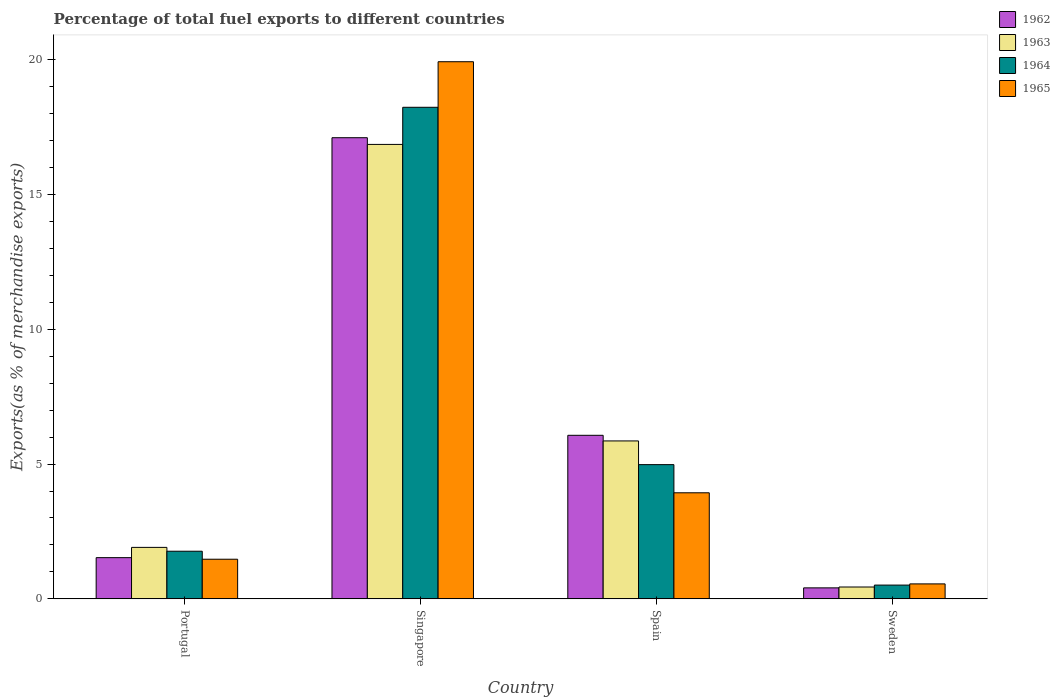How many different coloured bars are there?
Ensure brevity in your answer.  4. Are the number of bars on each tick of the X-axis equal?
Your response must be concise. Yes. How many bars are there on the 4th tick from the left?
Offer a terse response. 4. What is the label of the 3rd group of bars from the left?
Offer a terse response. Spain. What is the percentage of exports to different countries in 1965 in Spain?
Your answer should be very brief. 3.93. Across all countries, what is the maximum percentage of exports to different countries in 1964?
Your answer should be very brief. 18.23. Across all countries, what is the minimum percentage of exports to different countries in 1964?
Make the answer very short. 0.51. In which country was the percentage of exports to different countries in 1965 maximum?
Offer a very short reply. Singapore. What is the total percentage of exports to different countries in 1962 in the graph?
Offer a very short reply. 25.1. What is the difference between the percentage of exports to different countries in 1964 in Portugal and that in Spain?
Offer a very short reply. -3.21. What is the difference between the percentage of exports to different countries in 1963 in Singapore and the percentage of exports to different countries in 1965 in Sweden?
Offer a very short reply. 16.3. What is the average percentage of exports to different countries in 1965 per country?
Make the answer very short. 6.47. What is the difference between the percentage of exports to different countries of/in 1963 and percentage of exports to different countries of/in 1965 in Portugal?
Offer a very short reply. 0.44. In how many countries, is the percentage of exports to different countries in 1962 greater than 3 %?
Give a very brief answer. 2. What is the ratio of the percentage of exports to different countries in 1962 in Singapore to that in Sweden?
Provide a succinct answer. 41.99. What is the difference between the highest and the second highest percentage of exports to different countries in 1963?
Provide a short and direct response. 14.95. What is the difference between the highest and the lowest percentage of exports to different countries in 1964?
Give a very brief answer. 17.72. Is the sum of the percentage of exports to different countries in 1962 in Portugal and Sweden greater than the maximum percentage of exports to different countries in 1965 across all countries?
Provide a succinct answer. No. What does the 4th bar from the right in Sweden represents?
Provide a succinct answer. 1962. Is it the case that in every country, the sum of the percentage of exports to different countries in 1964 and percentage of exports to different countries in 1965 is greater than the percentage of exports to different countries in 1963?
Give a very brief answer. Yes. How many bars are there?
Give a very brief answer. 16. What is the difference between two consecutive major ticks on the Y-axis?
Offer a terse response. 5. Are the values on the major ticks of Y-axis written in scientific E-notation?
Offer a very short reply. No. Does the graph contain grids?
Provide a succinct answer. No. How many legend labels are there?
Make the answer very short. 4. How are the legend labels stacked?
Offer a terse response. Vertical. What is the title of the graph?
Your answer should be very brief. Percentage of total fuel exports to different countries. Does "2002" appear as one of the legend labels in the graph?
Make the answer very short. No. What is the label or title of the Y-axis?
Keep it short and to the point. Exports(as % of merchandise exports). What is the Exports(as % of merchandise exports) in 1962 in Portugal?
Your answer should be compact. 1.53. What is the Exports(as % of merchandise exports) in 1963 in Portugal?
Your answer should be very brief. 1.91. What is the Exports(as % of merchandise exports) of 1964 in Portugal?
Your answer should be compact. 1.77. What is the Exports(as % of merchandise exports) in 1965 in Portugal?
Your answer should be very brief. 1.47. What is the Exports(as % of merchandise exports) in 1962 in Singapore?
Provide a short and direct response. 17.1. What is the Exports(as % of merchandise exports) of 1963 in Singapore?
Your response must be concise. 16.85. What is the Exports(as % of merchandise exports) in 1964 in Singapore?
Offer a terse response. 18.23. What is the Exports(as % of merchandise exports) of 1965 in Singapore?
Give a very brief answer. 19.92. What is the Exports(as % of merchandise exports) in 1962 in Spain?
Your answer should be compact. 6.07. What is the Exports(as % of merchandise exports) of 1963 in Spain?
Give a very brief answer. 5.86. What is the Exports(as % of merchandise exports) of 1964 in Spain?
Ensure brevity in your answer.  4.98. What is the Exports(as % of merchandise exports) in 1965 in Spain?
Your answer should be compact. 3.93. What is the Exports(as % of merchandise exports) in 1962 in Sweden?
Your answer should be very brief. 0.41. What is the Exports(as % of merchandise exports) in 1963 in Sweden?
Provide a succinct answer. 0.44. What is the Exports(as % of merchandise exports) in 1964 in Sweden?
Provide a short and direct response. 0.51. What is the Exports(as % of merchandise exports) of 1965 in Sweden?
Make the answer very short. 0.55. Across all countries, what is the maximum Exports(as % of merchandise exports) in 1962?
Offer a very short reply. 17.1. Across all countries, what is the maximum Exports(as % of merchandise exports) of 1963?
Give a very brief answer. 16.85. Across all countries, what is the maximum Exports(as % of merchandise exports) in 1964?
Offer a terse response. 18.23. Across all countries, what is the maximum Exports(as % of merchandise exports) of 1965?
Offer a terse response. 19.92. Across all countries, what is the minimum Exports(as % of merchandise exports) in 1962?
Your answer should be compact. 0.41. Across all countries, what is the minimum Exports(as % of merchandise exports) in 1963?
Offer a very short reply. 0.44. Across all countries, what is the minimum Exports(as % of merchandise exports) of 1964?
Give a very brief answer. 0.51. Across all countries, what is the minimum Exports(as % of merchandise exports) in 1965?
Your answer should be compact. 0.55. What is the total Exports(as % of merchandise exports) of 1962 in the graph?
Provide a succinct answer. 25.1. What is the total Exports(as % of merchandise exports) of 1963 in the graph?
Offer a very short reply. 25.06. What is the total Exports(as % of merchandise exports) of 1964 in the graph?
Keep it short and to the point. 25.49. What is the total Exports(as % of merchandise exports) of 1965 in the graph?
Offer a very short reply. 25.88. What is the difference between the Exports(as % of merchandise exports) in 1962 in Portugal and that in Singapore?
Give a very brief answer. -15.58. What is the difference between the Exports(as % of merchandise exports) in 1963 in Portugal and that in Singapore?
Your answer should be very brief. -14.95. What is the difference between the Exports(as % of merchandise exports) of 1964 in Portugal and that in Singapore?
Your answer should be very brief. -16.47. What is the difference between the Exports(as % of merchandise exports) in 1965 in Portugal and that in Singapore?
Your answer should be compact. -18.45. What is the difference between the Exports(as % of merchandise exports) of 1962 in Portugal and that in Spain?
Your answer should be very brief. -4.54. What is the difference between the Exports(as % of merchandise exports) in 1963 in Portugal and that in Spain?
Make the answer very short. -3.95. What is the difference between the Exports(as % of merchandise exports) of 1964 in Portugal and that in Spain?
Offer a very short reply. -3.21. What is the difference between the Exports(as % of merchandise exports) in 1965 in Portugal and that in Spain?
Offer a terse response. -2.46. What is the difference between the Exports(as % of merchandise exports) in 1962 in Portugal and that in Sweden?
Your response must be concise. 1.12. What is the difference between the Exports(as % of merchandise exports) in 1963 in Portugal and that in Sweden?
Provide a short and direct response. 1.47. What is the difference between the Exports(as % of merchandise exports) in 1964 in Portugal and that in Sweden?
Ensure brevity in your answer.  1.26. What is the difference between the Exports(as % of merchandise exports) of 1965 in Portugal and that in Sweden?
Your answer should be compact. 0.91. What is the difference between the Exports(as % of merchandise exports) in 1962 in Singapore and that in Spain?
Offer a very short reply. 11.04. What is the difference between the Exports(as % of merchandise exports) in 1963 in Singapore and that in Spain?
Your response must be concise. 11. What is the difference between the Exports(as % of merchandise exports) in 1964 in Singapore and that in Spain?
Keep it short and to the point. 13.25. What is the difference between the Exports(as % of merchandise exports) in 1965 in Singapore and that in Spain?
Offer a terse response. 15.99. What is the difference between the Exports(as % of merchandise exports) in 1962 in Singapore and that in Sweden?
Provide a short and direct response. 16.7. What is the difference between the Exports(as % of merchandise exports) in 1963 in Singapore and that in Sweden?
Provide a succinct answer. 16.42. What is the difference between the Exports(as % of merchandise exports) of 1964 in Singapore and that in Sweden?
Your answer should be very brief. 17.72. What is the difference between the Exports(as % of merchandise exports) in 1965 in Singapore and that in Sweden?
Give a very brief answer. 19.37. What is the difference between the Exports(as % of merchandise exports) of 1962 in Spain and that in Sweden?
Your response must be concise. 5.66. What is the difference between the Exports(as % of merchandise exports) of 1963 in Spain and that in Sweden?
Provide a succinct answer. 5.42. What is the difference between the Exports(as % of merchandise exports) in 1964 in Spain and that in Sweden?
Your answer should be compact. 4.47. What is the difference between the Exports(as % of merchandise exports) of 1965 in Spain and that in Sweden?
Provide a short and direct response. 3.38. What is the difference between the Exports(as % of merchandise exports) in 1962 in Portugal and the Exports(as % of merchandise exports) in 1963 in Singapore?
Keep it short and to the point. -15.33. What is the difference between the Exports(as % of merchandise exports) in 1962 in Portugal and the Exports(as % of merchandise exports) in 1964 in Singapore?
Offer a terse response. -16.7. What is the difference between the Exports(as % of merchandise exports) of 1962 in Portugal and the Exports(as % of merchandise exports) of 1965 in Singapore?
Ensure brevity in your answer.  -18.39. What is the difference between the Exports(as % of merchandise exports) in 1963 in Portugal and the Exports(as % of merchandise exports) in 1964 in Singapore?
Offer a very short reply. -16.32. What is the difference between the Exports(as % of merchandise exports) in 1963 in Portugal and the Exports(as % of merchandise exports) in 1965 in Singapore?
Provide a short and direct response. -18.01. What is the difference between the Exports(as % of merchandise exports) in 1964 in Portugal and the Exports(as % of merchandise exports) in 1965 in Singapore?
Make the answer very short. -18.16. What is the difference between the Exports(as % of merchandise exports) of 1962 in Portugal and the Exports(as % of merchandise exports) of 1963 in Spain?
Your answer should be very brief. -4.33. What is the difference between the Exports(as % of merchandise exports) in 1962 in Portugal and the Exports(as % of merchandise exports) in 1964 in Spain?
Keep it short and to the point. -3.45. What is the difference between the Exports(as % of merchandise exports) of 1962 in Portugal and the Exports(as % of merchandise exports) of 1965 in Spain?
Offer a very short reply. -2.41. What is the difference between the Exports(as % of merchandise exports) of 1963 in Portugal and the Exports(as % of merchandise exports) of 1964 in Spain?
Offer a terse response. -3.07. What is the difference between the Exports(as % of merchandise exports) in 1963 in Portugal and the Exports(as % of merchandise exports) in 1965 in Spain?
Keep it short and to the point. -2.03. What is the difference between the Exports(as % of merchandise exports) of 1964 in Portugal and the Exports(as % of merchandise exports) of 1965 in Spain?
Give a very brief answer. -2.17. What is the difference between the Exports(as % of merchandise exports) in 1962 in Portugal and the Exports(as % of merchandise exports) in 1963 in Sweden?
Give a very brief answer. 1.09. What is the difference between the Exports(as % of merchandise exports) in 1962 in Portugal and the Exports(as % of merchandise exports) in 1964 in Sweden?
Your answer should be compact. 1.02. What is the difference between the Exports(as % of merchandise exports) in 1962 in Portugal and the Exports(as % of merchandise exports) in 1965 in Sweden?
Your answer should be very brief. 0.97. What is the difference between the Exports(as % of merchandise exports) in 1963 in Portugal and the Exports(as % of merchandise exports) in 1964 in Sweden?
Your response must be concise. 1.4. What is the difference between the Exports(as % of merchandise exports) of 1963 in Portugal and the Exports(as % of merchandise exports) of 1965 in Sweden?
Give a very brief answer. 1.35. What is the difference between the Exports(as % of merchandise exports) in 1964 in Portugal and the Exports(as % of merchandise exports) in 1965 in Sweden?
Your response must be concise. 1.21. What is the difference between the Exports(as % of merchandise exports) in 1962 in Singapore and the Exports(as % of merchandise exports) in 1963 in Spain?
Give a very brief answer. 11.25. What is the difference between the Exports(as % of merchandise exports) in 1962 in Singapore and the Exports(as % of merchandise exports) in 1964 in Spain?
Provide a short and direct response. 12.13. What is the difference between the Exports(as % of merchandise exports) in 1962 in Singapore and the Exports(as % of merchandise exports) in 1965 in Spain?
Offer a very short reply. 13.17. What is the difference between the Exports(as % of merchandise exports) of 1963 in Singapore and the Exports(as % of merchandise exports) of 1964 in Spain?
Offer a very short reply. 11.88. What is the difference between the Exports(as % of merchandise exports) in 1963 in Singapore and the Exports(as % of merchandise exports) in 1965 in Spain?
Ensure brevity in your answer.  12.92. What is the difference between the Exports(as % of merchandise exports) in 1964 in Singapore and the Exports(as % of merchandise exports) in 1965 in Spain?
Give a very brief answer. 14.3. What is the difference between the Exports(as % of merchandise exports) in 1962 in Singapore and the Exports(as % of merchandise exports) in 1963 in Sweden?
Keep it short and to the point. 16.66. What is the difference between the Exports(as % of merchandise exports) of 1962 in Singapore and the Exports(as % of merchandise exports) of 1964 in Sweden?
Ensure brevity in your answer.  16.59. What is the difference between the Exports(as % of merchandise exports) in 1962 in Singapore and the Exports(as % of merchandise exports) in 1965 in Sweden?
Offer a very short reply. 16.55. What is the difference between the Exports(as % of merchandise exports) of 1963 in Singapore and the Exports(as % of merchandise exports) of 1964 in Sweden?
Offer a terse response. 16.34. What is the difference between the Exports(as % of merchandise exports) of 1963 in Singapore and the Exports(as % of merchandise exports) of 1965 in Sweden?
Give a very brief answer. 16.3. What is the difference between the Exports(as % of merchandise exports) of 1964 in Singapore and the Exports(as % of merchandise exports) of 1965 in Sweden?
Offer a very short reply. 17.68. What is the difference between the Exports(as % of merchandise exports) in 1962 in Spain and the Exports(as % of merchandise exports) in 1963 in Sweden?
Provide a succinct answer. 5.63. What is the difference between the Exports(as % of merchandise exports) in 1962 in Spain and the Exports(as % of merchandise exports) in 1964 in Sweden?
Offer a terse response. 5.56. What is the difference between the Exports(as % of merchandise exports) in 1962 in Spain and the Exports(as % of merchandise exports) in 1965 in Sweden?
Offer a very short reply. 5.51. What is the difference between the Exports(as % of merchandise exports) of 1963 in Spain and the Exports(as % of merchandise exports) of 1964 in Sweden?
Offer a terse response. 5.35. What is the difference between the Exports(as % of merchandise exports) in 1963 in Spain and the Exports(as % of merchandise exports) in 1965 in Sweden?
Give a very brief answer. 5.3. What is the difference between the Exports(as % of merchandise exports) of 1964 in Spain and the Exports(as % of merchandise exports) of 1965 in Sweden?
Your response must be concise. 4.42. What is the average Exports(as % of merchandise exports) of 1962 per country?
Offer a very short reply. 6.28. What is the average Exports(as % of merchandise exports) in 1963 per country?
Provide a succinct answer. 6.27. What is the average Exports(as % of merchandise exports) in 1964 per country?
Ensure brevity in your answer.  6.37. What is the average Exports(as % of merchandise exports) in 1965 per country?
Your response must be concise. 6.47. What is the difference between the Exports(as % of merchandise exports) of 1962 and Exports(as % of merchandise exports) of 1963 in Portugal?
Give a very brief answer. -0.38. What is the difference between the Exports(as % of merchandise exports) of 1962 and Exports(as % of merchandise exports) of 1964 in Portugal?
Offer a very short reply. -0.24. What is the difference between the Exports(as % of merchandise exports) in 1962 and Exports(as % of merchandise exports) in 1965 in Portugal?
Ensure brevity in your answer.  0.06. What is the difference between the Exports(as % of merchandise exports) in 1963 and Exports(as % of merchandise exports) in 1964 in Portugal?
Offer a terse response. 0.14. What is the difference between the Exports(as % of merchandise exports) of 1963 and Exports(as % of merchandise exports) of 1965 in Portugal?
Provide a succinct answer. 0.44. What is the difference between the Exports(as % of merchandise exports) of 1964 and Exports(as % of merchandise exports) of 1965 in Portugal?
Provide a succinct answer. 0.3. What is the difference between the Exports(as % of merchandise exports) in 1962 and Exports(as % of merchandise exports) in 1963 in Singapore?
Make the answer very short. 0.25. What is the difference between the Exports(as % of merchandise exports) of 1962 and Exports(as % of merchandise exports) of 1964 in Singapore?
Ensure brevity in your answer.  -1.13. What is the difference between the Exports(as % of merchandise exports) in 1962 and Exports(as % of merchandise exports) in 1965 in Singapore?
Offer a very short reply. -2.82. What is the difference between the Exports(as % of merchandise exports) of 1963 and Exports(as % of merchandise exports) of 1964 in Singapore?
Offer a terse response. -1.38. What is the difference between the Exports(as % of merchandise exports) of 1963 and Exports(as % of merchandise exports) of 1965 in Singapore?
Provide a succinct answer. -3.07. What is the difference between the Exports(as % of merchandise exports) of 1964 and Exports(as % of merchandise exports) of 1965 in Singapore?
Your answer should be very brief. -1.69. What is the difference between the Exports(as % of merchandise exports) of 1962 and Exports(as % of merchandise exports) of 1963 in Spain?
Offer a terse response. 0.21. What is the difference between the Exports(as % of merchandise exports) in 1962 and Exports(as % of merchandise exports) in 1964 in Spain?
Give a very brief answer. 1.09. What is the difference between the Exports(as % of merchandise exports) in 1962 and Exports(as % of merchandise exports) in 1965 in Spain?
Provide a succinct answer. 2.13. What is the difference between the Exports(as % of merchandise exports) in 1963 and Exports(as % of merchandise exports) in 1964 in Spain?
Make the answer very short. 0.88. What is the difference between the Exports(as % of merchandise exports) of 1963 and Exports(as % of merchandise exports) of 1965 in Spain?
Offer a very short reply. 1.92. What is the difference between the Exports(as % of merchandise exports) of 1964 and Exports(as % of merchandise exports) of 1965 in Spain?
Provide a succinct answer. 1.04. What is the difference between the Exports(as % of merchandise exports) in 1962 and Exports(as % of merchandise exports) in 1963 in Sweden?
Your response must be concise. -0.03. What is the difference between the Exports(as % of merchandise exports) in 1962 and Exports(as % of merchandise exports) in 1964 in Sweden?
Offer a terse response. -0.1. What is the difference between the Exports(as % of merchandise exports) in 1962 and Exports(as % of merchandise exports) in 1965 in Sweden?
Provide a succinct answer. -0.15. What is the difference between the Exports(as % of merchandise exports) in 1963 and Exports(as % of merchandise exports) in 1964 in Sweden?
Provide a short and direct response. -0.07. What is the difference between the Exports(as % of merchandise exports) of 1963 and Exports(as % of merchandise exports) of 1965 in Sweden?
Your answer should be very brief. -0.12. What is the difference between the Exports(as % of merchandise exports) of 1964 and Exports(as % of merchandise exports) of 1965 in Sweden?
Keep it short and to the point. -0.04. What is the ratio of the Exports(as % of merchandise exports) of 1962 in Portugal to that in Singapore?
Your response must be concise. 0.09. What is the ratio of the Exports(as % of merchandise exports) of 1963 in Portugal to that in Singapore?
Your answer should be compact. 0.11. What is the ratio of the Exports(as % of merchandise exports) in 1964 in Portugal to that in Singapore?
Keep it short and to the point. 0.1. What is the ratio of the Exports(as % of merchandise exports) in 1965 in Portugal to that in Singapore?
Keep it short and to the point. 0.07. What is the ratio of the Exports(as % of merchandise exports) in 1962 in Portugal to that in Spain?
Your response must be concise. 0.25. What is the ratio of the Exports(as % of merchandise exports) of 1963 in Portugal to that in Spain?
Make the answer very short. 0.33. What is the ratio of the Exports(as % of merchandise exports) of 1964 in Portugal to that in Spain?
Your answer should be compact. 0.35. What is the ratio of the Exports(as % of merchandise exports) of 1965 in Portugal to that in Spain?
Provide a short and direct response. 0.37. What is the ratio of the Exports(as % of merchandise exports) of 1962 in Portugal to that in Sweden?
Keep it short and to the point. 3.75. What is the ratio of the Exports(as % of merchandise exports) of 1963 in Portugal to that in Sweden?
Offer a terse response. 4.34. What is the ratio of the Exports(as % of merchandise exports) in 1964 in Portugal to that in Sweden?
Offer a very short reply. 3.46. What is the ratio of the Exports(as % of merchandise exports) of 1965 in Portugal to that in Sweden?
Give a very brief answer. 2.65. What is the ratio of the Exports(as % of merchandise exports) in 1962 in Singapore to that in Spain?
Your answer should be compact. 2.82. What is the ratio of the Exports(as % of merchandise exports) of 1963 in Singapore to that in Spain?
Your response must be concise. 2.88. What is the ratio of the Exports(as % of merchandise exports) of 1964 in Singapore to that in Spain?
Give a very brief answer. 3.66. What is the ratio of the Exports(as % of merchandise exports) in 1965 in Singapore to that in Spain?
Provide a succinct answer. 5.06. What is the ratio of the Exports(as % of merchandise exports) of 1962 in Singapore to that in Sweden?
Keep it short and to the point. 41.99. What is the ratio of the Exports(as % of merchandise exports) of 1963 in Singapore to that in Sweden?
Give a very brief answer. 38.35. What is the ratio of the Exports(as % of merchandise exports) of 1964 in Singapore to that in Sweden?
Make the answer very short. 35.72. What is the ratio of the Exports(as % of merchandise exports) of 1965 in Singapore to that in Sweden?
Offer a very short reply. 35.92. What is the ratio of the Exports(as % of merchandise exports) of 1962 in Spain to that in Sweden?
Offer a terse response. 14.89. What is the ratio of the Exports(as % of merchandise exports) of 1963 in Spain to that in Sweden?
Ensure brevity in your answer.  13.33. What is the ratio of the Exports(as % of merchandise exports) of 1964 in Spain to that in Sweden?
Your answer should be compact. 9.75. What is the ratio of the Exports(as % of merchandise exports) in 1965 in Spain to that in Sweden?
Offer a terse response. 7.09. What is the difference between the highest and the second highest Exports(as % of merchandise exports) in 1962?
Offer a very short reply. 11.04. What is the difference between the highest and the second highest Exports(as % of merchandise exports) of 1963?
Ensure brevity in your answer.  11. What is the difference between the highest and the second highest Exports(as % of merchandise exports) in 1964?
Your answer should be compact. 13.25. What is the difference between the highest and the second highest Exports(as % of merchandise exports) in 1965?
Give a very brief answer. 15.99. What is the difference between the highest and the lowest Exports(as % of merchandise exports) of 1962?
Provide a succinct answer. 16.7. What is the difference between the highest and the lowest Exports(as % of merchandise exports) of 1963?
Keep it short and to the point. 16.42. What is the difference between the highest and the lowest Exports(as % of merchandise exports) in 1964?
Make the answer very short. 17.72. What is the difference between the highest and the lowest Exports(as % of merchandise exports) in 1965?
Offer a very short reply. 19.37. 